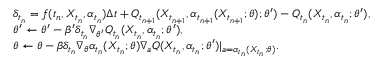Convert formula to latex. <formula><loc_0><loc_0><loc_500><loc_500>\begin{array} { r l } & { \delta _ { t _ { n } } = f ( t _ { n } , X _ { t _ { n } } , \alpha _ { t _ { n } } ) \Delta t + Q _ { t _ { n + 1 } } ( X _ { t _ { n + 1 } } , \alpha _ { t _ { n + 1 } } ( X _ { t _ { n + 1 } } ; \theta ) ; \theta ^ { \prime } ) - Q _ { t _ { n } } ( X _ { t _ { n } } , \alpha _ { t _ { n } } ; \theta ^ { \prime } ) , } \\ & { \theta ^ { \prime } \leftarrow \theta ^ { \prime } - \beta ^ { \prime } \delta _ { t _ { n } } \nabla _ { \theta ^ { \prime } } Q _ { t _ { n } } ( X _ { t _ { n } } , \alpha _ { t _ { n } } ; \theta ^ { \prime } ) , } \\ & { \theta \leftarrow \theta - \beta \delta _ { t _ { n } } \nabla _ { \theta } \alpha _ { t _ { n } } ( X _ { t _ { n } } ; \theta ) \nabla _ { a } Q ( X _ { t _ { n } } , \alpha _ { t _ { n } } ; \theta ^ { \prime } ) | _ { a = \alpha _ { t _ { n } } ( X _ { t _ { n } } ; \theta ) } . } \end{array}</formula> 